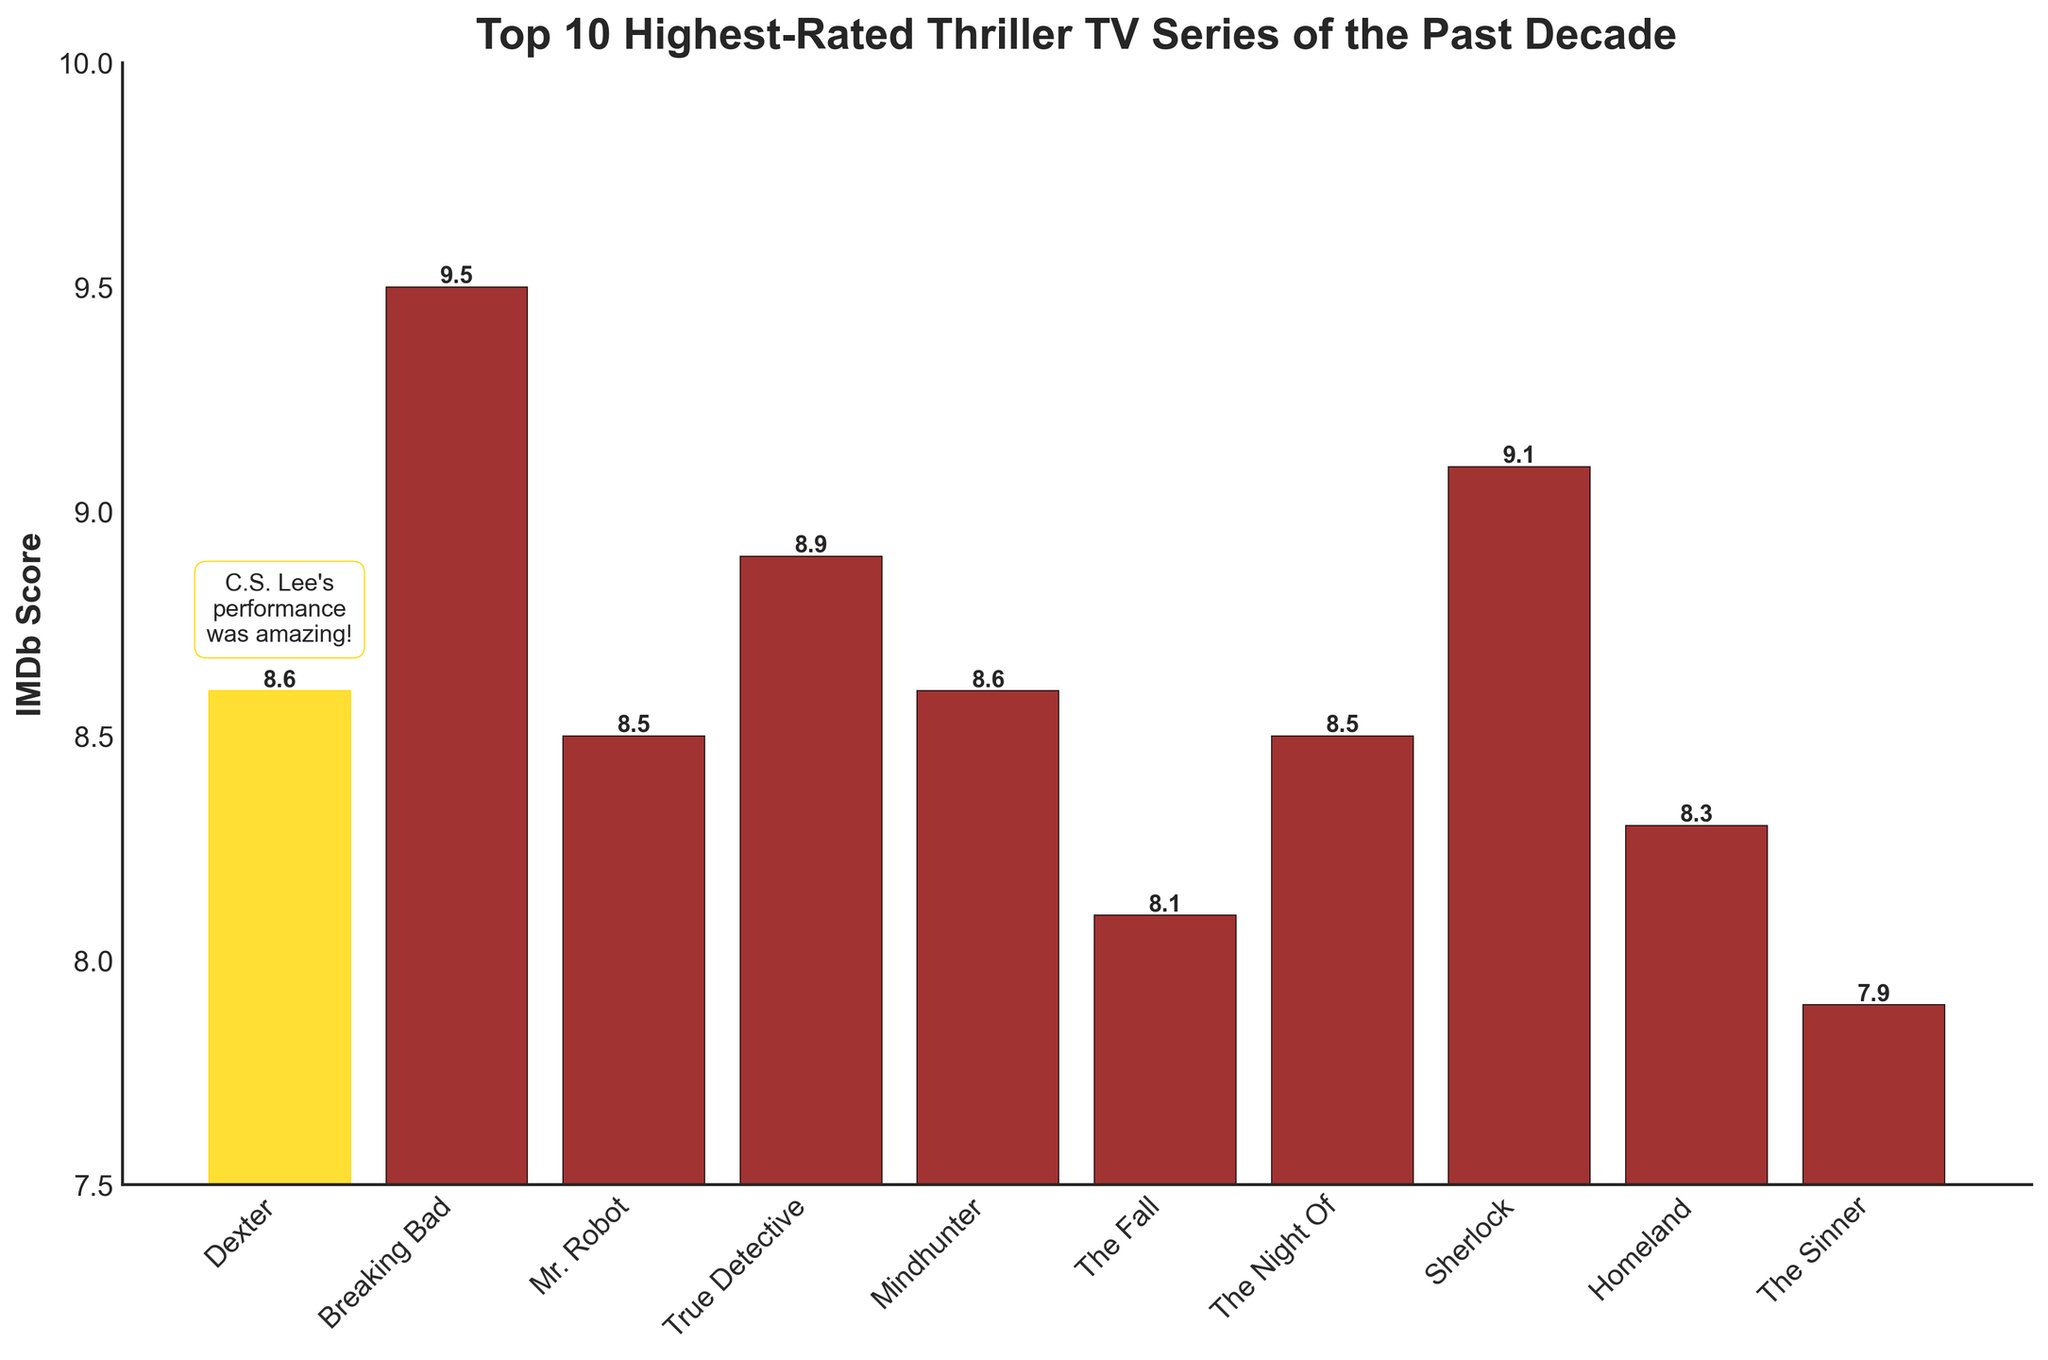Which thriller TV series has the highest IMDb score? Scan for the highest bar, which corresponds to Breaking Bad with a score of 9.5
Answer: Breaking Bad Which two TV series have the same IMDb score, and what is that score? Look for bars with identical heights and label values. Dexter and Mindhunter both have an IMDb score of 8.6
Answer: Dexter and Mindhunter, 8.6 Which series has a lower IMDb score, Mr. Robot or The Night Of? Compare the height of the bars for Mr. Robot and The Night Of. Mr. Robot has a score of 8.5, and The Night Of has the same score, so they are equal.
Answer: Mr. Robot and The Night Of What is the average IMDb score of all the series listed? Sum all the IMDb scores and divide by the number of series: (8.6 + 9.5 + 8.5 + 8.9 + 8.6 + 8.1 + 8.5 + 9.1 + 8.3 + 7.9) / 10 = 8.6
Answer: 8.6 Which series has the lowest IMDb score, and what is it? Identify the shortest bar, which corresponds to The Sinner with the score of 7.9
Answer: The Sinner, 7.9 How many series have an IMDb score higher than 9.0? Identify and count the bars with scores higher than 9.0. Breaking Bad and Sherlock have scores of 9.5 and 9.1 respectively
Answer: 2 How much higher is the IMDb score of Breaking Bad compared to Homeland? Subtract Homeland's score from Breaking Bad's score: 9.5 - 8.3 = 1.2
Answer: 1.2 Which series is highlighted with the text "C.S. Lee's performance was amazing!" and what is its IMDb score? Locate the bar with the highlighted comment, which is Dexter, and note its score of 8.6
Answer: Dexter, 8.6 